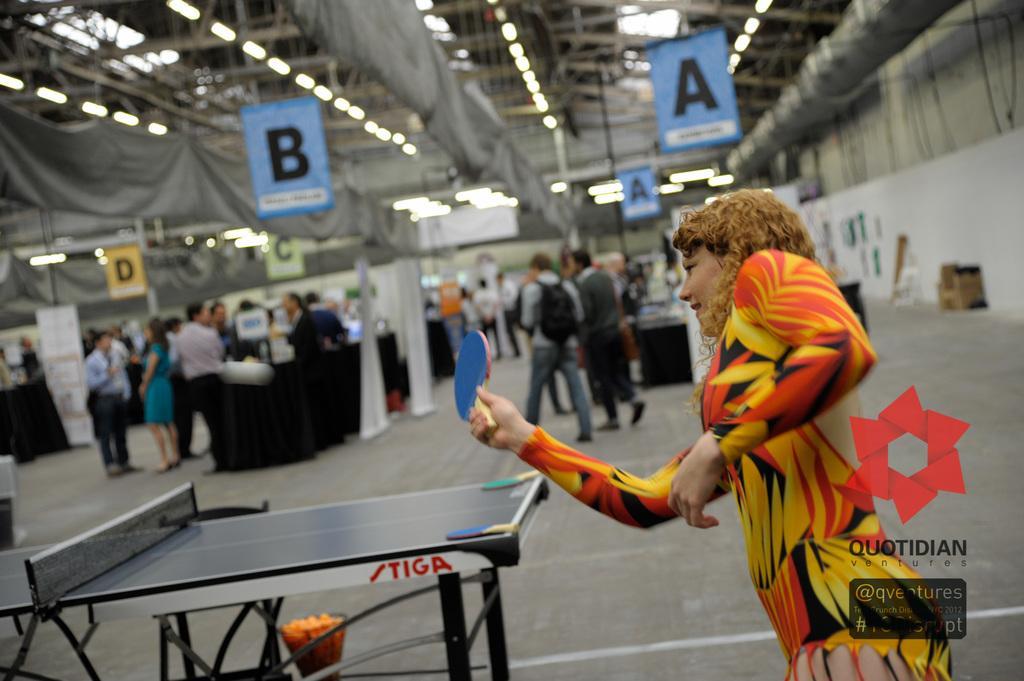In one or two sentences, can you explain what this image depicts? A woman is holding bat, here there is table on it there are bats, here people are standing and walking. 